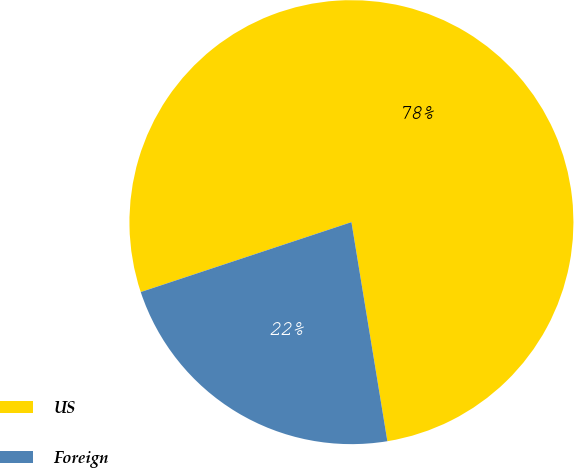Convert chart to OTSL. <chart><loc_0><loc_0><loc_500><loc_500><pie_chart><fcel>US<fcel>Foreign<nl><fcel>77.51%<fcel>22.49%<nl></chart> 